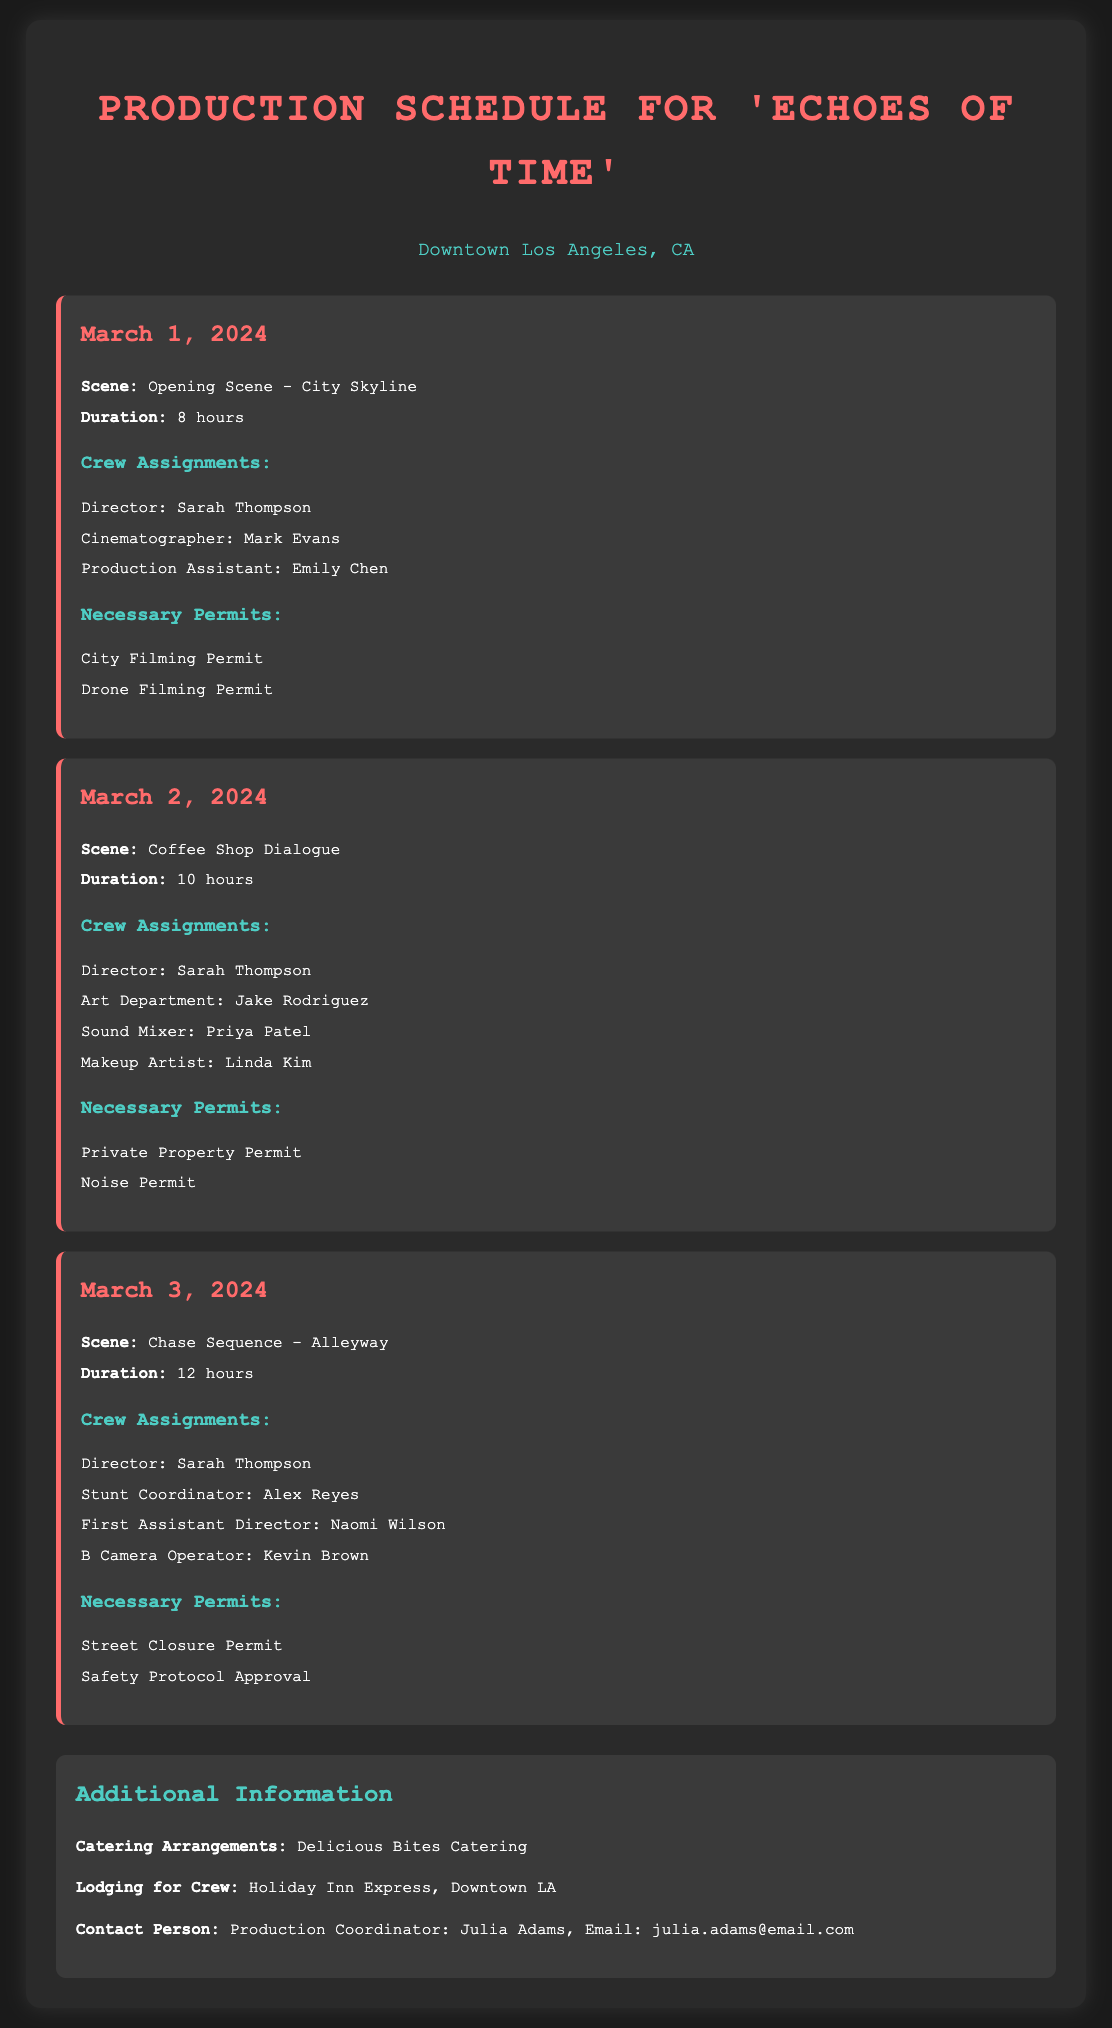What is the filming location? The filming location is stated as "Downtown Los Angeles, CA" in the document.
Answer: Downtown Los Angeles, CA Who is the director for all the scenes? The director for all the scenes is mentioned multiple times in the document as Sarah Thompson.
Answer: Sarah Thompson How many hours is the shooting duration for the Coffee Shop Dialogue scene? The shooting duration for the Coffee Shop Dialogue scene is listed as 10 hours in the document.
Answer: 10 hours What permit is needed for the Chase Sequence in the Alleyway? The necessary permits for the Chase Sequence include "Street Closure Permit" as stated in the document.
Answer: Street Closure Permit Which catering service is arranged for the crew? The document indicates the catering arrangements are with "Delicious Bites Catering."
Answer: Delicious Bites Catering How many crew members are assigned to the Chase Sequence? The Chase Sequence has four crew members assigned as listed in the document.
Answer: Four What is the date of the Opening Scene shoot? The date for the Opening Scene shoot is provided as March 1, 2024, in the document.
Answer: March 1, 2024 Who is the contact person for the production? The document states the contact person is the Production Coordinator, Julia Adams.
Answer: Julia Adams What is the duration of the scene with the City Skyline? The duration for the scene is listed as 8 hours in the document.
Answer: 8 hours 